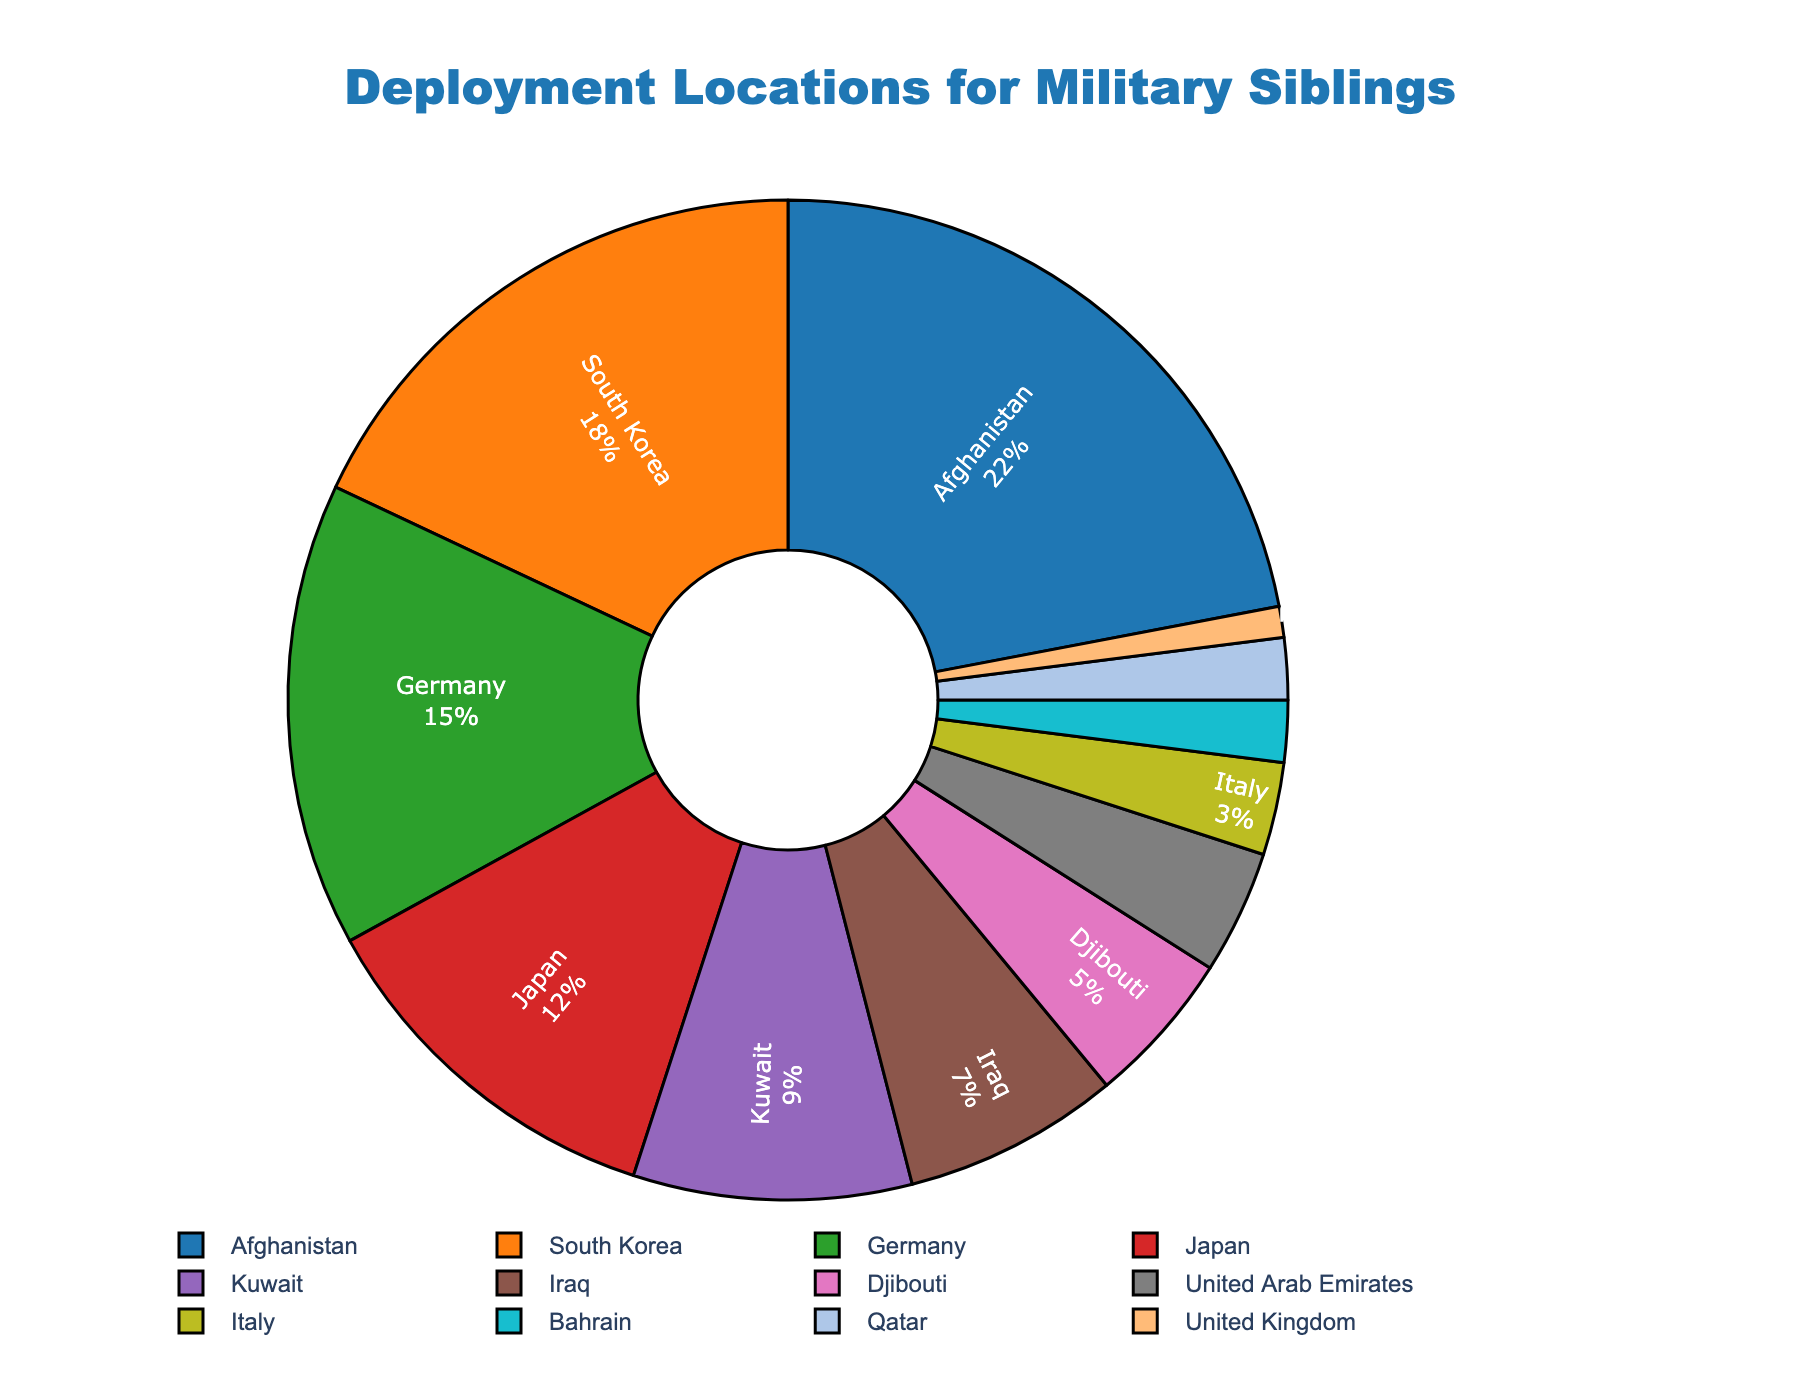Which location has the highest percentage of deployment? The pie chart shows that Afghanistan has the highest percentage of deployment. This can be identified by both the size of the slice and the number 22% labeled clearly.
Answer: Afghanistan What is the combined percentage of deployments to Europe (Germany, Italy, United Kingdom)? To find this, sum the percentages of Germany (15%), Italy (3%), and United Kingdom (1%). The total is 15 + 3 + 1 = 19%.
Answer: 19% Which location has a smaller percentage of deployments, Qatar or Bahrain? By comparing the slice sizes and percentages, Qatar is labeled with 2% and Bahrain with 2%. Both have the same percentage of 2%.
Answer: They are equal What percentage of deployments are in the Middle East (Afghanistan, Kuwait, Iraq, Djibouti, United Arab Emirates, Bahrain, Qatar)? Adding the percentages from the given locations: Afghanistan (22%), Kuwait (9%), Iraq (7%), Djibouti (5%), United Arab Emirates (4%), Bahrain (2%), Qatar (2%). The total is 22 + 9 + 7 + 5 + 4 + 2 + 2 = 51%.
Answer: 51% Which regions of the world represented have a slice color that includes a shade of blue? The colors are not provided directly, but based on common color palettes, shades of blue are typically used for Germany and United Arab Emirates.
Answer: Germany, United Arab Emirates Is South Korea's percentage of deployment larger than Japan's? Comparing the two, South Korea (18%) is larger than Japan (12%) as observed from both the labeled percentages and the relative slice sizes.
Answer: Yes How does the percentage of deployment to Japan compare to that of Kuwait? Japan has 12% and Kuwait has 9%. Therefore, Japan has a higher percentage of deployments compared to Kuwait.
Answer: Japan is higher What is the percentage difference between South Korea and Germany deployments? To find the difference, subtract Germany's percentage (15%) from South Korea's (18%). The difference is 18 - 15 = 3%.
Answer: 3% If we combine the percentages of Iraq and Djibouti, does it surpass South Korea's percentage? Adding Iraq (7%) and Djibouti (5%) gives 7 + 5 = 12%. South Korea is 18%, so the combined percentage does not surpass South Korea.
Answer: No 